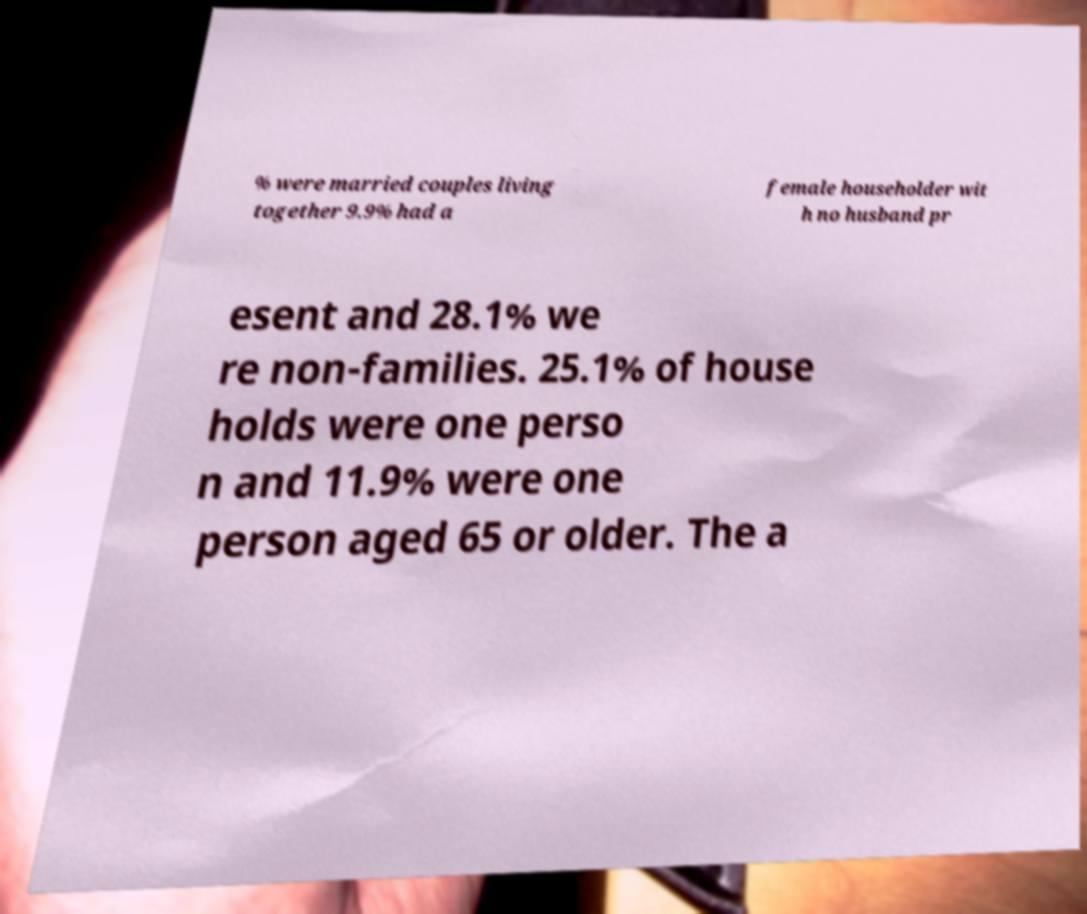I need the written content from this picture converted into text. Can you do that? % were married couples living together 9.9% had a female householder wit h no husband pr esent and 28.1% we re non-families. 25.1% of house holds were one perso n and 11.9% were one person aged 65 or older. The a 